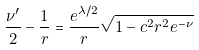<formula> <loc_0><loc_0><loc_500><loc_500>\frac { \nu ^ { \prime } } { 2 } - \frac { 1 } { r } = \frac { e ^ { \lambda / 2 } } { r } \sqrt { 1 - c ^ { 2 } r ^ { 2 } e ^ { - \nu } }</formula> 